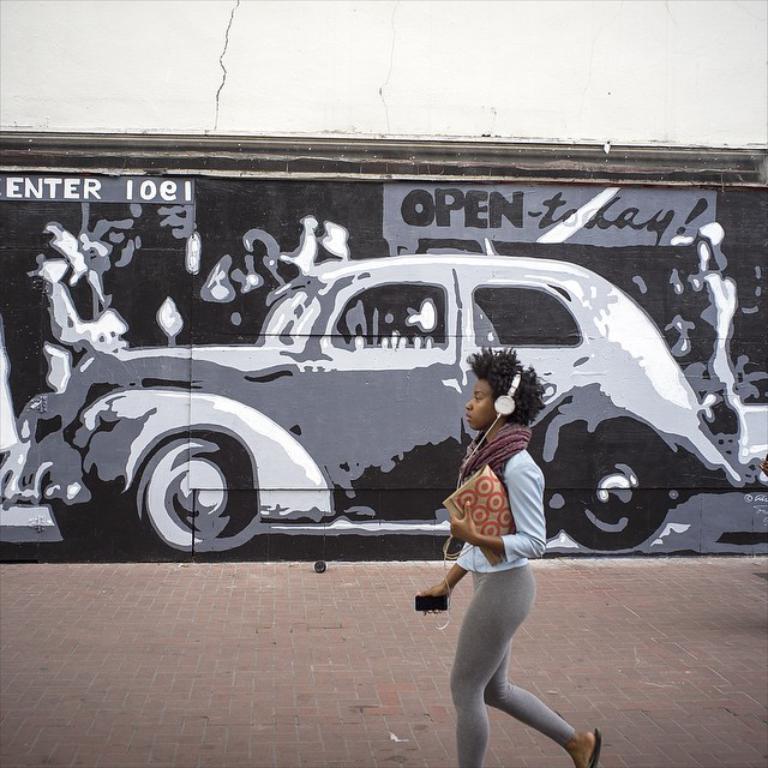Could you give a brief overview of what you see in this image? This picture is clicked outside. In the foreground there is a person wearing headphones, holding some objects and walking on the pavement. In the background there is a wall and we can see the picture of a car and the text on the wall. 